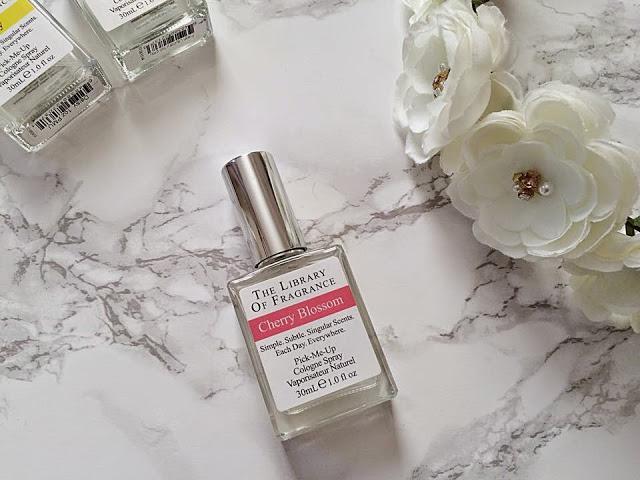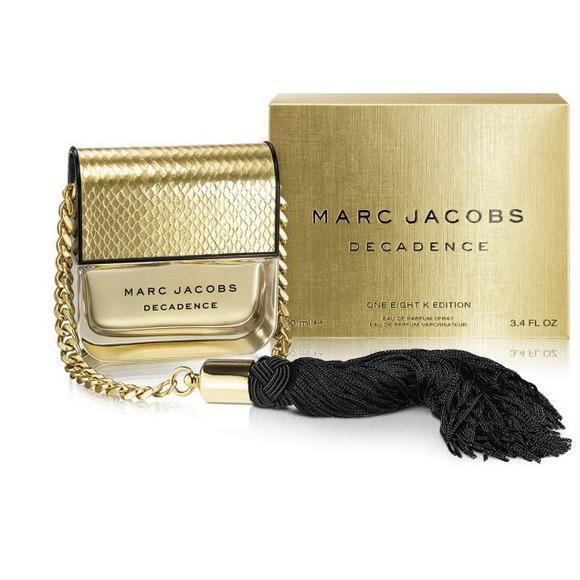The first image is the image on the left, the second image is the image on the right. For the images displayed, is the sentence "there is a perfume container with a chain and tassles" factually correct? Answer yes or no. Yes. The first image is the image on the left, the second image is the image on the right. Considering the images on both sides, is "A golden bottle of perfume with a golden chain and black tassel is sitting next to a matching golden box." valid? Answer yes or no. Yes. 